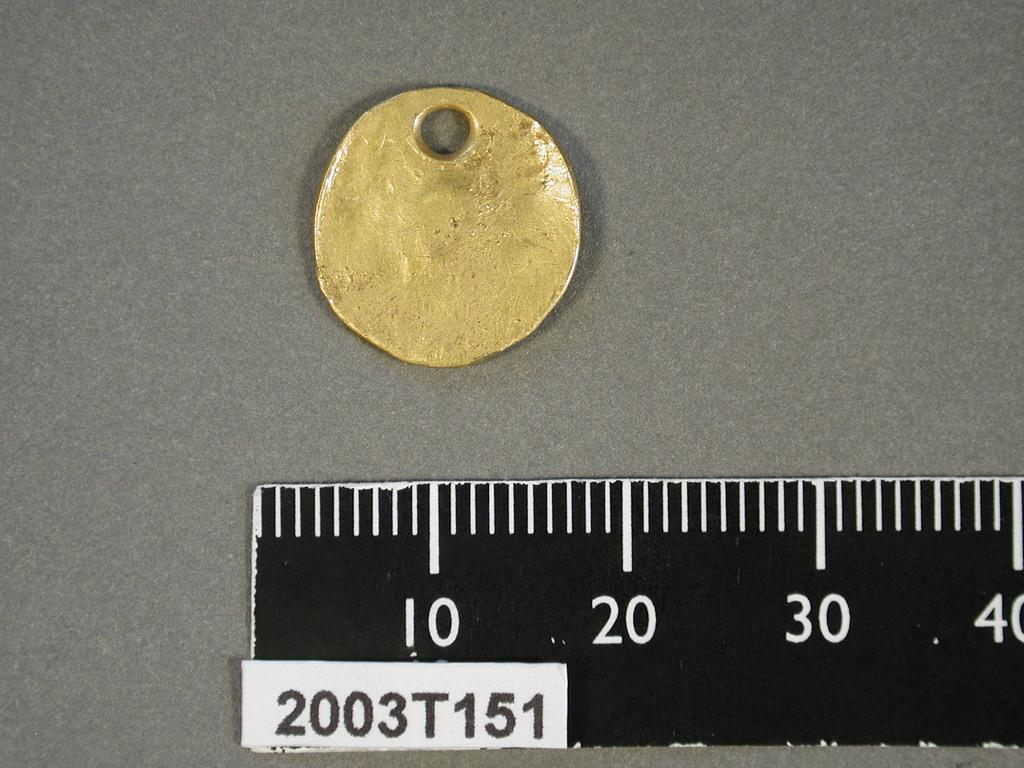<image>
Summarize the visual content of the image. Gold colored coin along with a black and white runner showing numbers 2003T151 